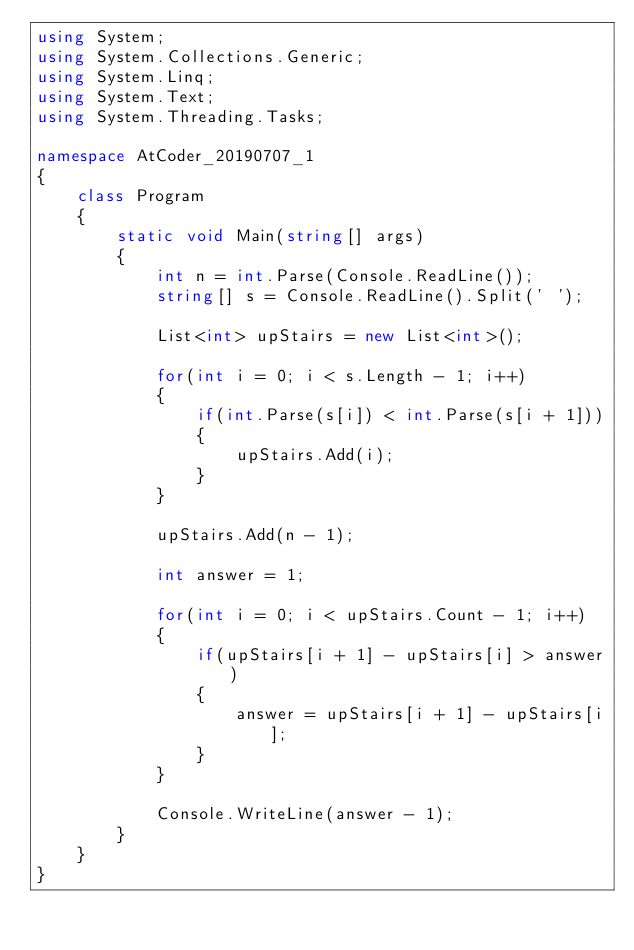<code> <loc_0><loc_0><loc_500><loc_500><_C#_>using System;
using System.Collections.Generic;
using System.Linq;
using System.Text;
using System.Threading.Tasks;

namespace AtCoder_20190707_1
{
    class Program
    {
        static void Main(string[] args)
        {            
            int n = int.Parse(Console.ReadLine());
            string[] s = Console.ReadLine().Split(' ');

            List<int> upStairs = new List<int>();

            for(int i = 0; i < s.Length - 1; i++)
            {
                if(int.Parse(s[i]) < int.Parse(s[i + 1]))
                {
                    upStairs.Add(i);
                }
            }

            upStairs.Add(n - 1);

            int answer = 1;

            for(int i = 0; i < upStairs.Count - 1; i++)
            {
                if(upStairs[i + 1] - upStairs[i] > answer)
                {
                    answer = upStairs[i + 1] - upStairs[i];
                }
            }

            Console.WriteLine(answer - 1);
        }
    }
}
</code> 